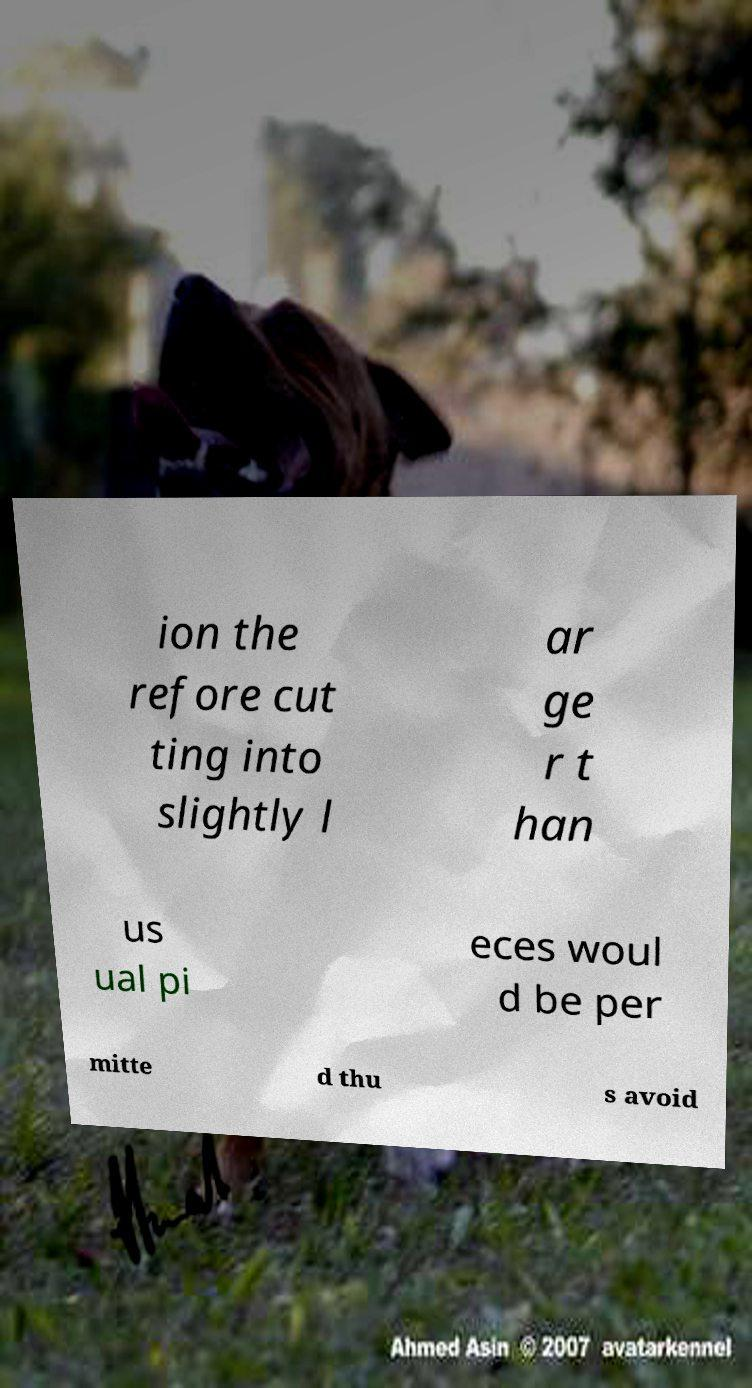Can you read and provide the text displayed in the image?This photo seems to have some interesting text. Can you extract and type it out for me? ion the refore cut ting into slightly l ar ge r t han us ual pi eces woul d be per mitte d thu s avoid 